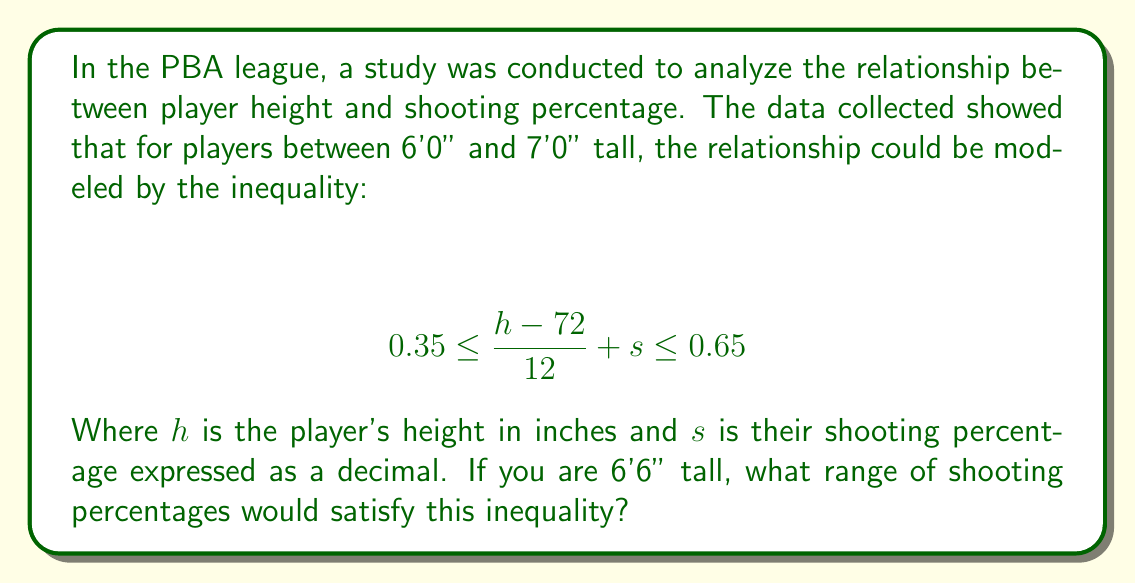Teach me how to tackle this problem. Let's approach this step-by-step:

1) First, we need to convert the player's height from feet and inches to just inches:
   6'6" = (6 × 12) + 6 = 78 inches

2) Now, we can substitute this value for $h$ in our inequality:
   $$ 0.35 \leq \frac{78-72}{12} + s \leq 0.65 $$

3) Simplify the fraction:
   $$ 0.35 \leq \frac{6}{12} + s \leq 0.65 $$
   $$ 0.35 \leq 0.5 + s \leq 0.65 $$

4) Now, let's isolate $s$ by subtracting 0.5 from each part of the inequality:
   $$ 0.35 - 0.5 \leq s \leq 0.65 - 0.5 $$
   $$ -0.15 \leq s \leq 0.15 $$

5) Since shooting percentage can't be negative, we can adjust the lower bound to 0:
   $$ 0 \leq s \leq 0.15 $$

6) Convert the decimal to a percentage:
   $$ 0\% \leq s \leq 15\% $$

Therefore, for a player who is 6'6" tall, their shooting percentage should be between 0% and 15% to satisfy the given inequality.
Answer: 0% to 15% 